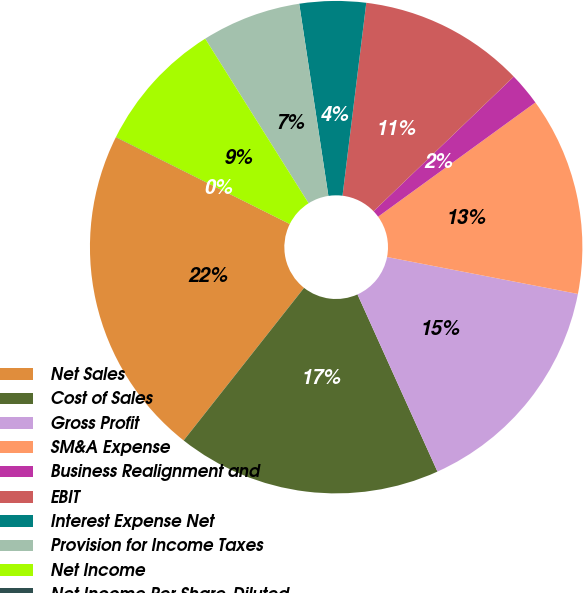Convert chart. <chart><loc_0><loc_0><loc_500><loc_500><pie_chart><fcel>Net Sales<fcel>Cost of Sales<fcel>Gross Profit<fcel>SM&A Expense<fcel>Business Realignment and<fcel>EBIT<fcel>Interest Expense Net<fcel>Provision for Income Taxes<fcel>Net Income<fcel>Net Income Per Share-Diluted<nl><fcel>21.73%<fcel>17.38%<fcel>15.21%<fcel>13.04%<fcel>2.18%<fcel>10.87%<fcel>4.35%<fcel>6.53%<fcel>8.7%<fcel>0.01%<nl></chart> 